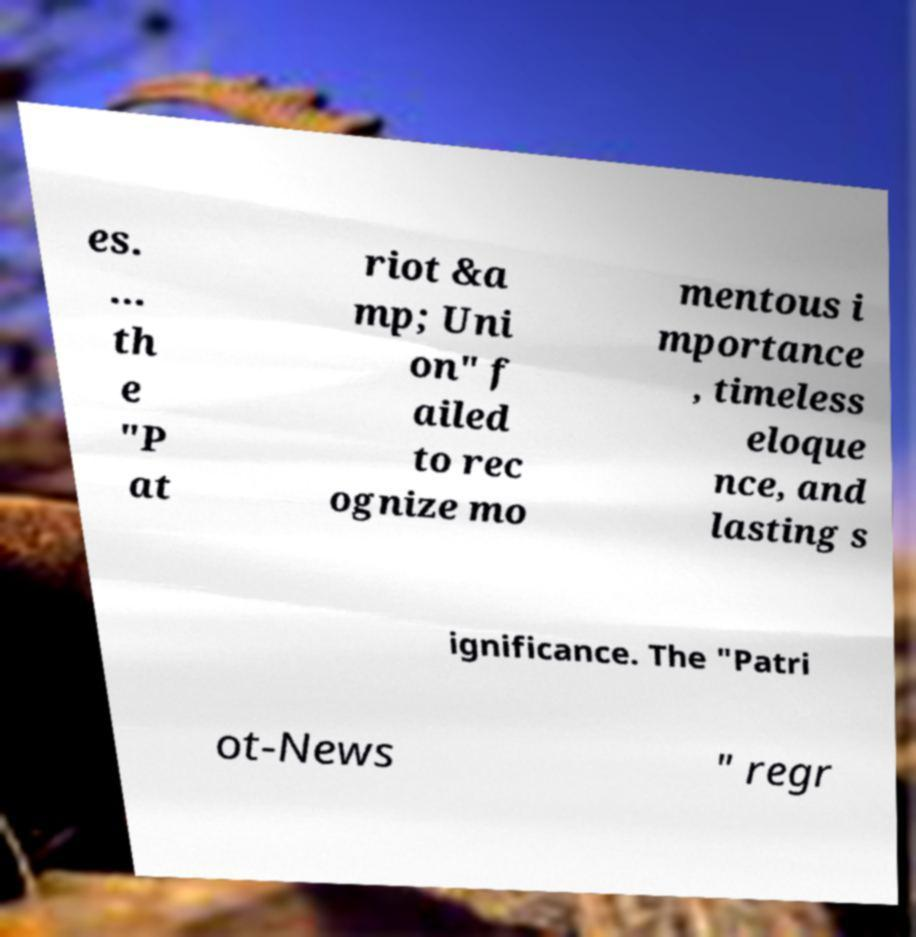There's text embedded in this image that I need extracted. Can you transcribe it verbatim? es. ... th e "P at riot &a mp; Uni on" f ailed to rec ognize mo mentous i mportance , timeless eloque nce, and lasting s ignificance. The "Patri ot-News " regr 